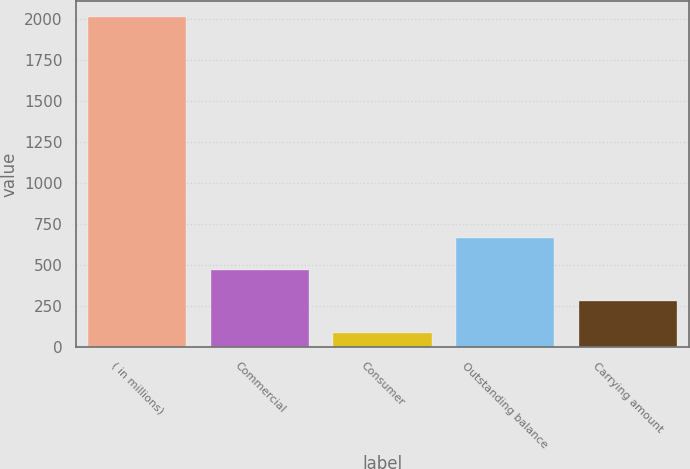<chart> <loc_0><loc_0><loc_500><loc_500><bar_chart><fcel>( in millions)<fcel>Commercial<fcel>Consumer<fcel>Outstanding balance<fcel>Carrying amount<nl><fcel>2008<fcel>471.2<fcel>87<fcel>663.3<fcel>279.1<nl></chart> 